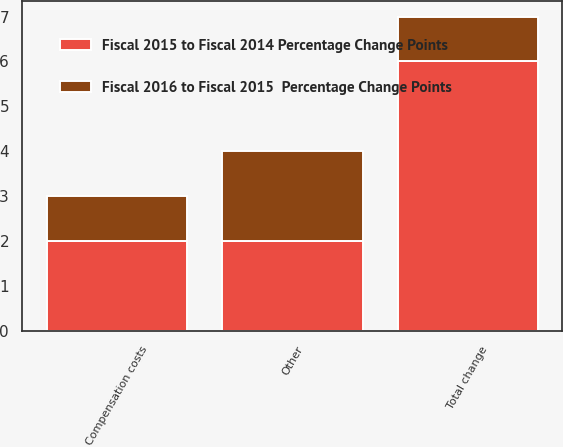Convert chart. <chart><loc_0><loc_0><loc_500><loc_500><stacked_bar_chart><ecel><fcel>Compensation costs<fcel>Other<fcel>Total change<nl><fcel>Fiscal 2015 to Fiscal 2014 Percentage Change Points<fcel>2<fcel>2<fcel>6<nl><fcel>Fiscal 2016 to Fiscal 2015  Percentage Change Points<fcel>1<fcel>2<fcel>1<nl></chart> 